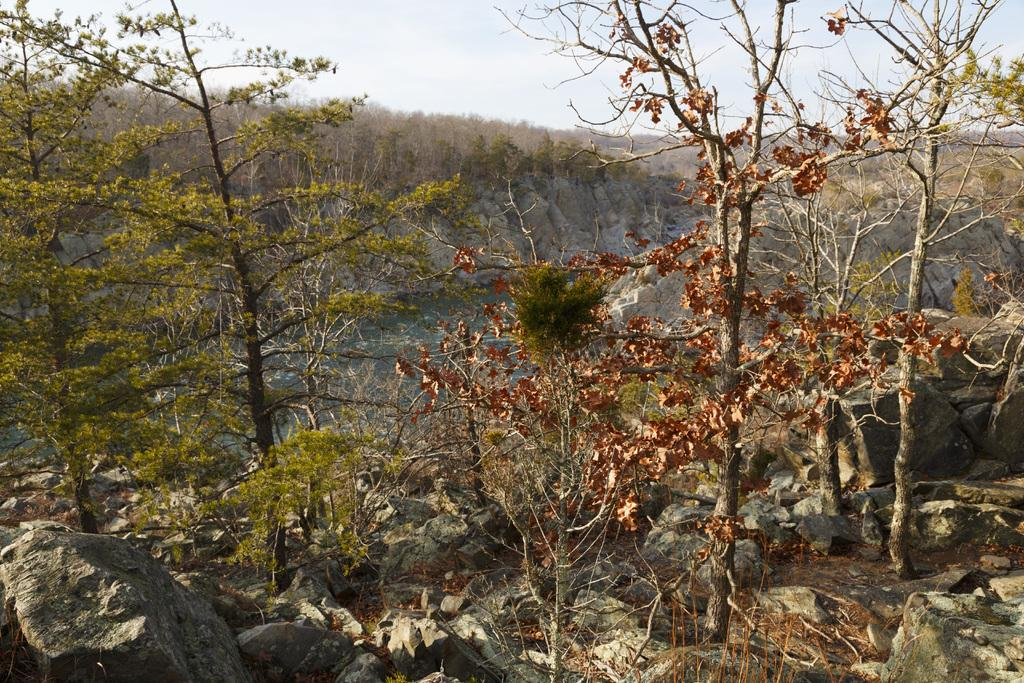What type of natural landform can be seen in the image? There are mountains in the image. What type of vegetation is present in the image? There are trees in the image. What is visible at the top of the image? The sky is visible at the top of the image. What is visible at the bottom of the image? There is water and ground visible at the bottom of the image. How many eyes can be seen in the image? There are no eyes present in the image. What type of bone is visible in the image? There are no bones visible in the image. 